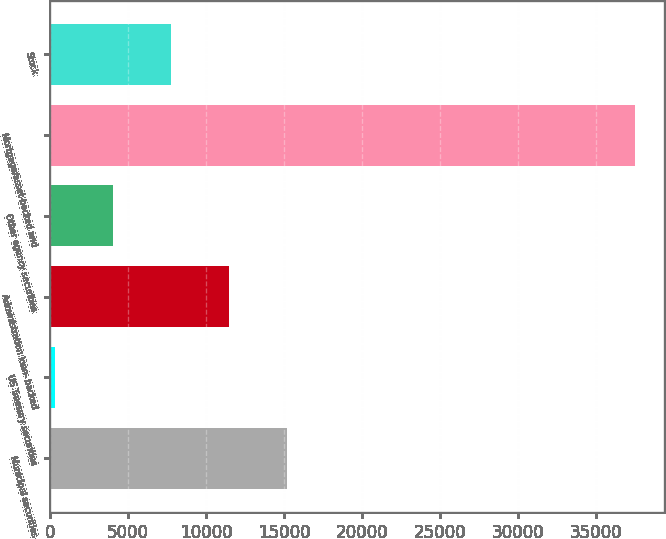Convert chart. <chart><loc_0><loc_0><loc_500><loc_500><bar_chart><fcel>Municipal securities<fcel>US Treasury securities<fcel>Administration loan- backed<fcel>Other agency securities<fcel>Mortgage/asset-backed and<fcel>Stock<nl><fcel>15173.6<fcel>304<fcel>11456.2<fcel>4021.4<fcel>37478<fcel>7738.8<nl></chart> 